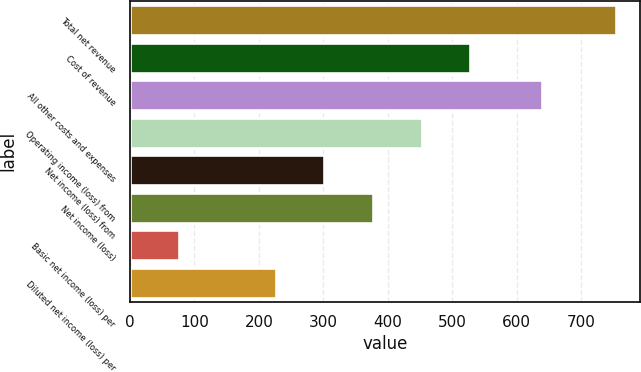<chart> <loc_0><loc_0><loc_500><loc_500><bar_chart><fcel>Total net revenue<fcel>Cost of revenue<fcel>All other costs and expenses<fcel>Operating income (loss) from<fcel>Net income (loss) from<fcel>Net income (loss)<fcel>Basic net income (loss) per<fcel>Diluted net income (loss) per<nl><fcel>754<fcel>527.82<fcel>639<fcel>452.44<fcel>301.68<fcel>377.06<fcel>75.54<fcel>226.3<nl></chart> 